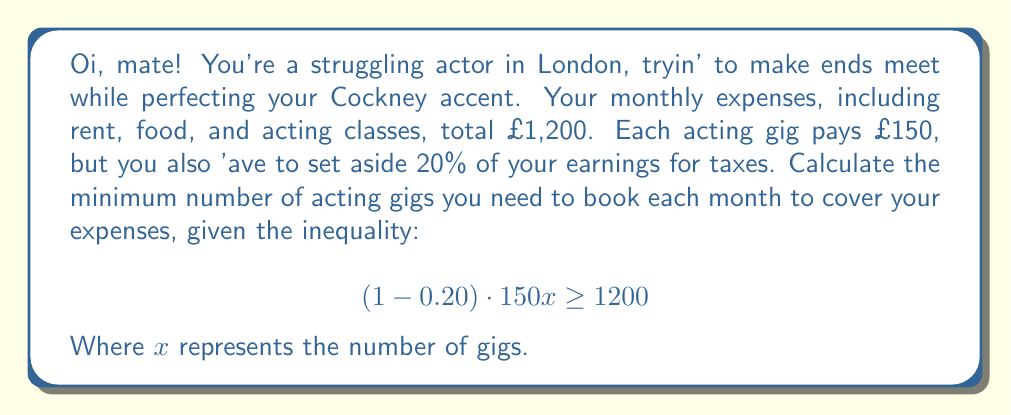Help me with this question. Let's break this down step by step, guv'nor:

1) First, let's simplify the left side of the inequality:
   $$(1 - 0.20) \cdot 150x = 0.80 \cdot 150x = 120x$$

2) Now our inequality looks like this:
   $$120x \geq 1200$$

3) To solve for $x$, we divide both sides by 120:
   $$x \geq \frac{1200}{120} = 10$$

4) Since $x$ represents the number of gigs, it must be a whole number. Therefore, we need to round up to the nearest integer.

5) The minimum number of gigs needed is the smallest integer greater than or equal to 10, which is 10 itself.

6) Let's verify:
   With 10 gigs: $120 \cdot 10 = 1200$, which exactly covers the expenses.
   With 9 gigs: $120 \cdot 9 = 1080$, which is not enough to cover expenses.

Therefore, you need at least 10 gigs to cover your monthly expenses.
Answer: The minimum number of acting gigs needed is 10. 